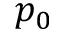Convert formula to latex. <formula><loc_0><loc_0><loc_500><loc_500>p _ { 0 }</formula> 